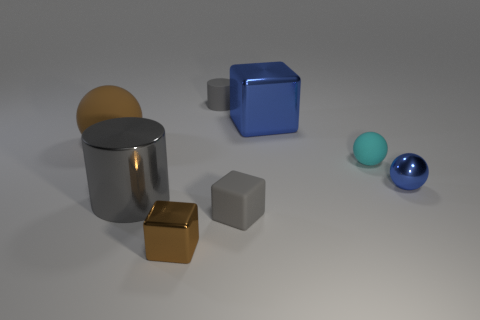Are there any large shiny objects of the same shape as the big rubber object?
Offer a very short reply. No. What is the size of the metallic cube behind the shiny block in front of the tiny gray rubber object that is in front of the small cylinder?
Make the answer very short. Large. Are there the same number of blue spheres that are on the left side of the brown metal block and blue spheres left of the brown matte thing?
Your answer should be compact. Yes. What is the size of the brown object that is made of the same material as the tiny gray cube?
Ensure brevity in your answer.  Large. The large matte sphere is what color?
Your response must be concise. Brown. How many metallic objects are the same color as the tiny rubber cylinder?
Your answer should be compact. 1. There is a gray cylinder that is the same size as the blue metallic block; what is it made of?
Keep it short and to the point. Metal. There is a big object to the left of the gray metallic thing; is there a matte cylinder on the left side of it?
Your response must be concise. No. How many other objects are the same color as the metal cylinder?
Make the answer very short. 2. What is the size of the brown shiny thing?
Provide a succinct answer. Small. 